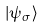<formula> <loc_0><loc_0><loc_500><loc_500>| \psi _ { \sigma } \rangle</formula> 